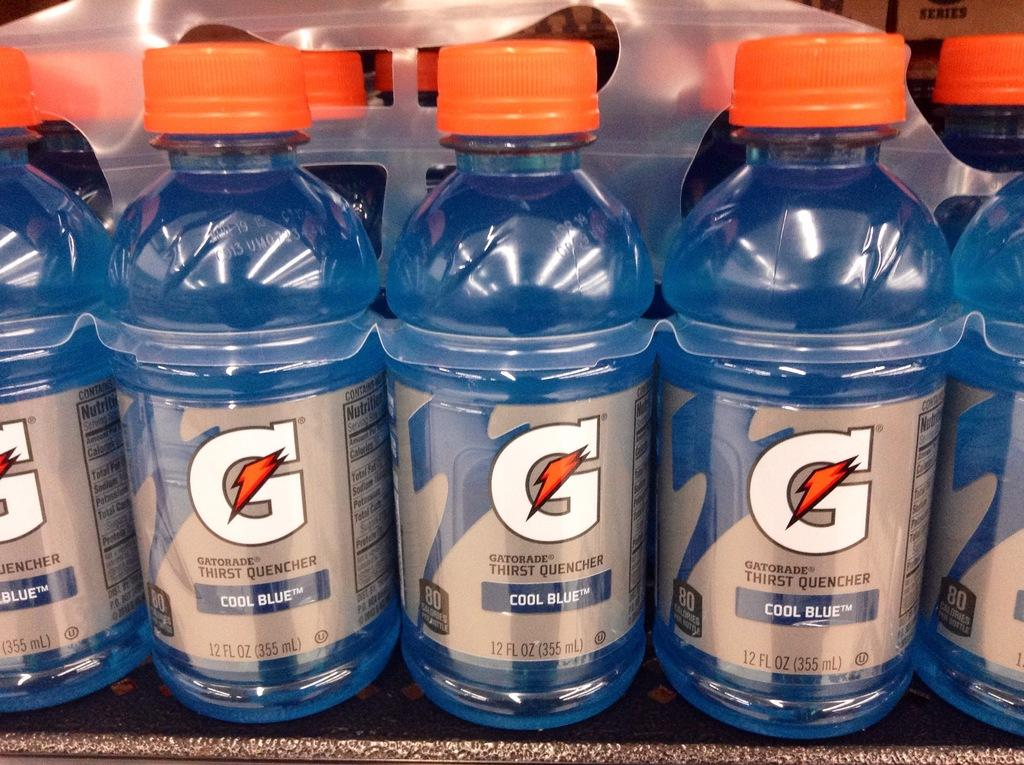What color are the bottles in the image? The bottles in the image are blue. What color are the lids on the bottles? The lids on the bottles are orange. What type of religion is practiced in the image? There is no indication of any religious practice or symbol in the image; it only features blue bottles with orange lids. 